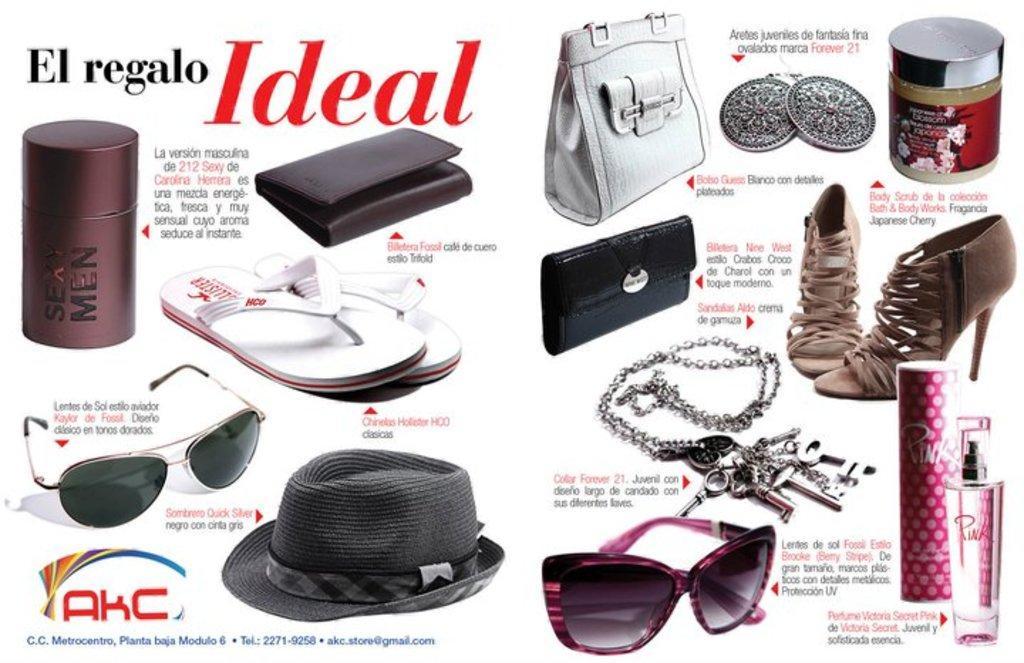Describe this image in one or two sentences. This is a poster. In this poster something is written. Also there are perfume bottles, purse, footwear, goggles, sandals, chain with keys and many other items. 